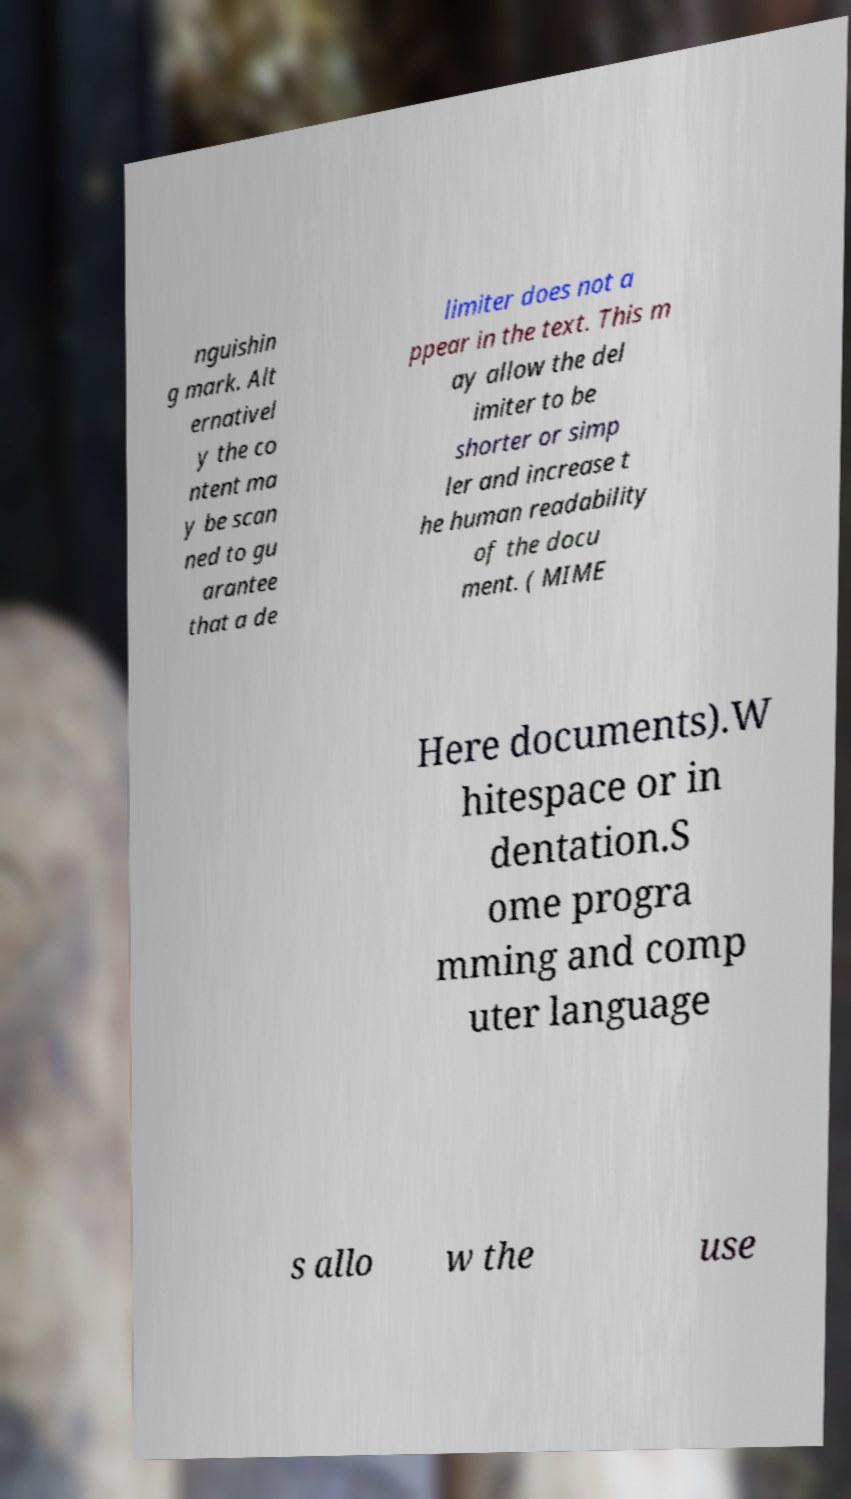What messages or text are displayed in this image? I need them in a readable, typed format. nguishin g mark. Alt ernativel y the co ntent ma y be scan ned to gu arantee that a de limiter does not a ppear in the text. This m ay allow the del imiter to be shorter or simp ler and increase t he human readability of the docu ment. ( MIME Here documents).W hitespace or in dentation.S ome progra mming and comp uter language s allo w the use 